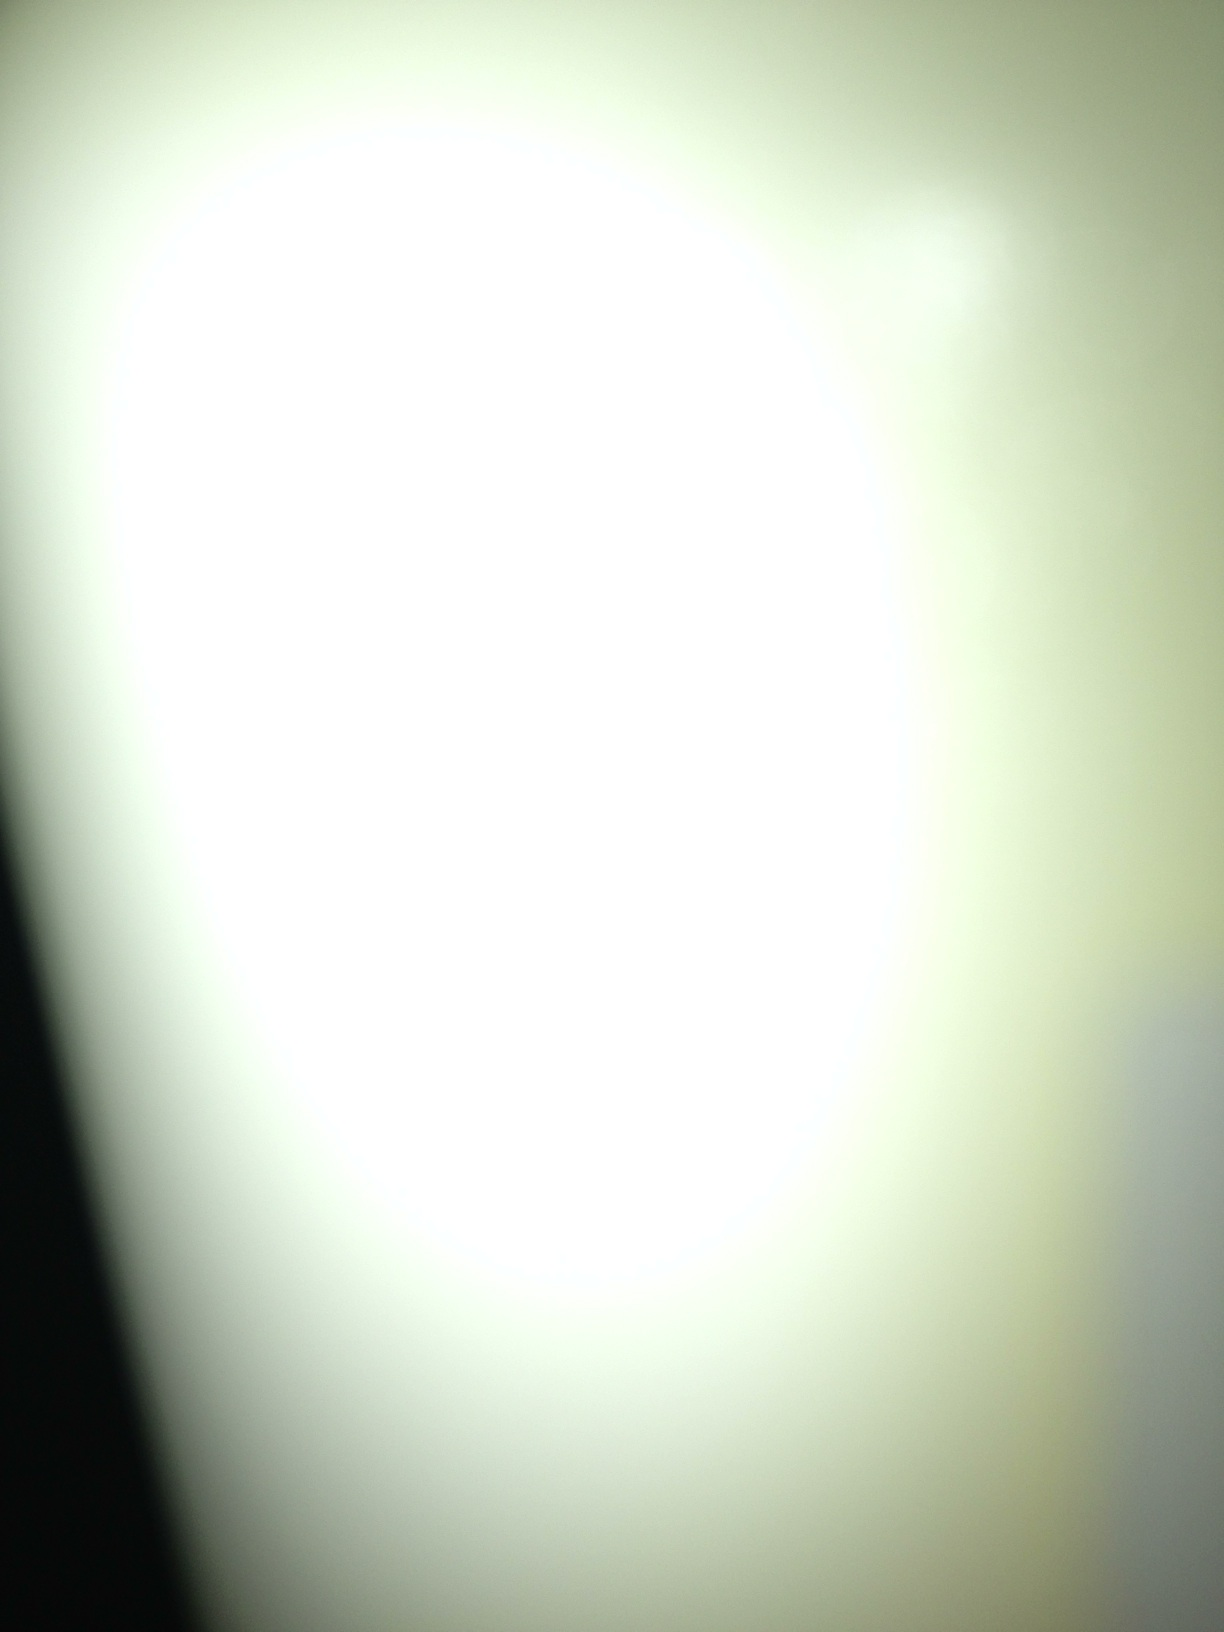Describe two realistic scenarios that this image could be a part of. Scenario 1 (Long): This image could be a photograph taken during a nighttime experiment where a group of scientists attempts to create a new form of sustainable energy. The bright central light is the core of their experimental reactor, which emits excessive light during a test run. The surrounding darkness represents the lab around it, slightly illuminated by the experimental light source. The experiment's success holds the promise of solving the energy crisis and paving the way for a brighter, more sustainable future. Scenario 2 (Short): This image could simply be a close-up shot of a lamp taken by an amateur photographer experimenting with focus and exposure. The blurred effect was unintended but created an interesting abstract photo. 